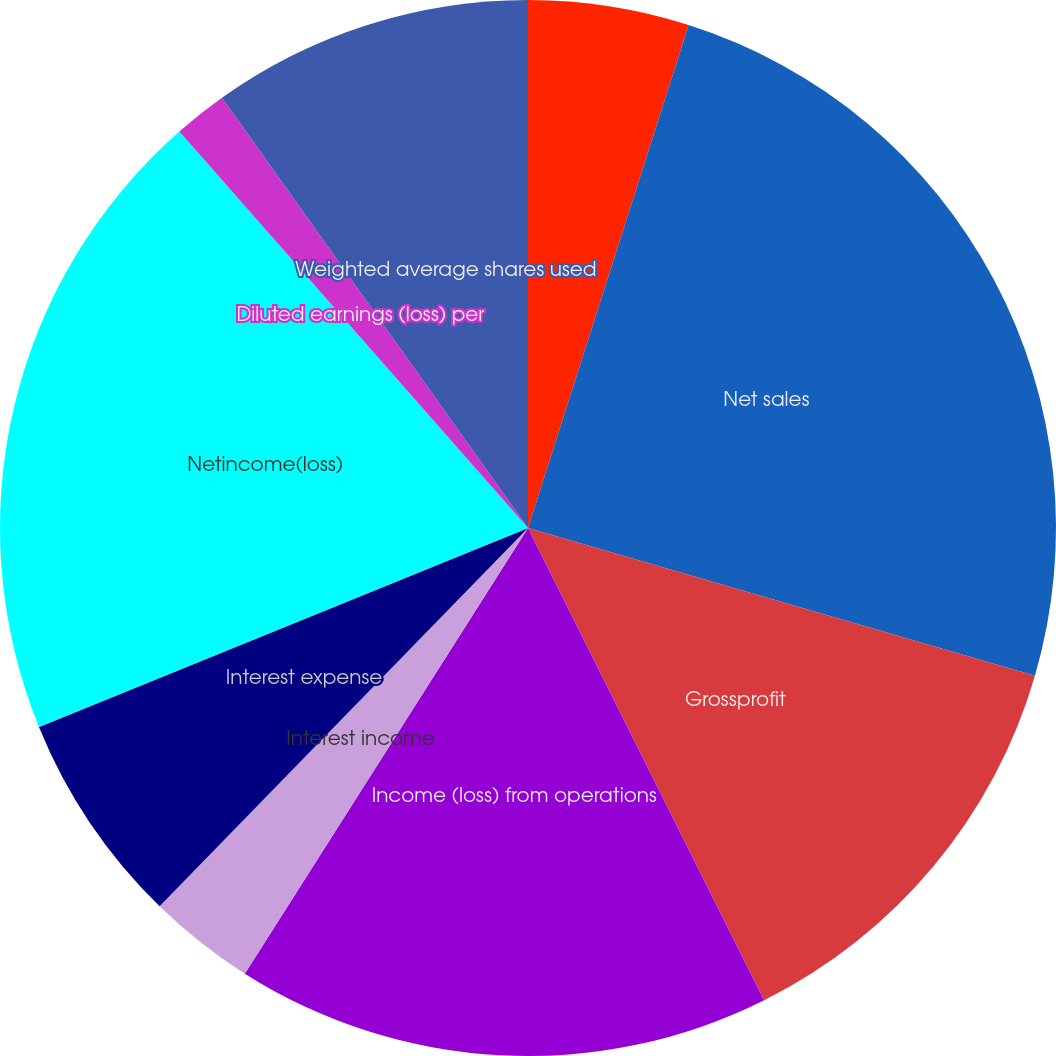Convert chart to OTSL. <chart><loc_0><loc_0><loc_500><loc_500><pie_chart><fcel>Net cash provided by (used in)<fcel>Net sales<fcel>Grossprofit<fcel>Income (loss) from operations<fcel>Interest income<fcel>Interest expense<fcel>Netincome(loss)<fcel>Basic earnings (loss) per<fcel>Diluted earnings (loss) per<fcel>Weighted average shares used<nl><fcel>4.92%<fcel>24.59%<fcel>13.11%<fcel>16.39%<fcel>3.28%<fcel>6.56%<fcel>19.67%<fcel>0.0%<fcel>1.64%<fcel>9.84%<nl></chart> 